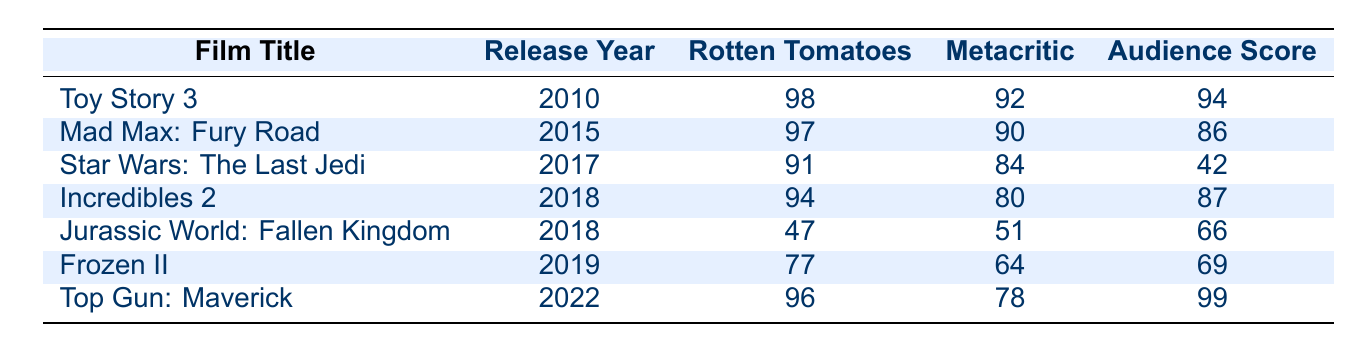What is the Rotten Tomatoes score for "Incredibles 2"? The Rotten Tomatoes score for "Incredibles 2" is listed in the table under the respective column. Looking directly at the row for "Incredibles 2," it shows a score of 94.
Answer: 94 Which film released in 2018 has the lowest Metacritic score? The films listed for 2018 are "Incredibles 2" and "Jurassic World: Fallen Kingdom." Their respective Metacritic scores are 80 and 51. Comparing these, "Jurassic World: Fallen Kingdom" has the lower score of 51.
Answer: Jurassic World: Fallen Kingdom True or False: "Top Gun: Maverick" has an audience score higher than 90. The audience score for "Top Gun: Maverick" is 99, which is indeed higher than 90, thus making the statement true.
Answer: True What is the average Rotten Tomatoes score of the sequels released between 2010 and 2019? The Rotten Tomatoes scores for films from this period are 98 (Toy Story 3), 97 (Mad Max: Fury Road), 91 (Star Wars: The Last Jedi), 94 (Incredibles 2), 47 (Jurassic World: Fallen Kingdom), and 77 (Frozen II). Adding these scores gives a sum of 504, and there are 6 films, so the average is 504 / 6 = 84.
Answer: 84 Which film released in 2017 has the largest difference between its Rotten Tomatoes score and audience score? Analyzing the data for Star Wars: The Last Jedi, the Rotten Tomatoes score is 91 and the audience score is 42, giving a difference of 49. The only other film from 2017 is "Star Wars: The Last Jedi," so this is the only data point to consider.
Answer: 49 